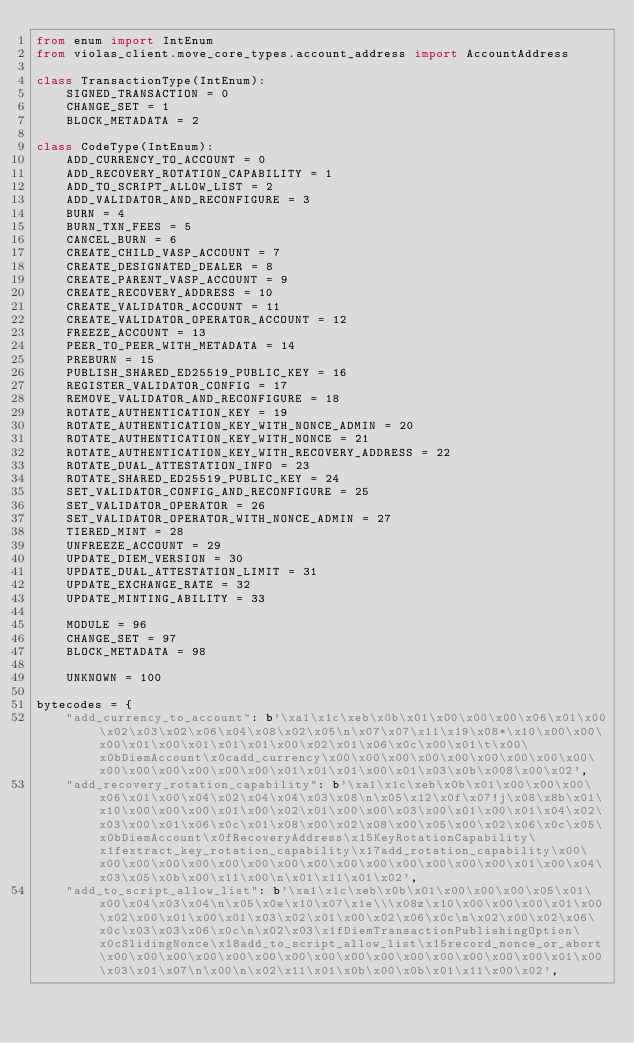Convert code to text. <code><loc_0><loc_0><loc_500><loc_500><_Python_>from enum import IntEnum
from violas_client.move_core_types.account_address import AccountAddress

class TransactionType(IntEnum):
    SIGNED_TRANSACTION = 0
    CHANGE_SET = 1
    BLOCK_METADATA = 2

class CodeType(IntEnum):
    ADD_CURRENCY_TO_ACCOUNT = 0
    ADD_RECOVERY_ROTATION_CAPABILITY = 1
    ADD_TO_SCRIPT_ALLOW_LIST = 2
    ADD_VALIDATOR_AND_RECONFIGURE = 3
    BURN = 4
    BURN_TXN_FEES = 5
    CANCEL_BURN = 6
    CREATE_CHILD_VASP_ACCOUNT = 7
    CREATE_DESIGNATED_DEALER = 8
    CREATE_PARENT_VASP_ACCOUNT = 9
    CREATE_RECOVERY_ADDRESS = 10
    CREATE_VALIDATOR_ACCOUNT = 11
    CREATE_VALIDATOR_OPERATOR_ACCOUNT = 12
    FREEZE_ACCOUNT = 13
    PEER_TO_PEER_WITH_METADATA = 14
    PREBURN = 15
    PUBLISH_SHARED_ED25519_PUBLIC_KEY = 16
    REGISTER_VALIDATOR_CONFIG = 17
    REMOVE_VALIDATOR_AND_RECONFIGURE = 18
    ROTATE_AUTHENTICATION_KEY = 19
    ROTATE_AUTHENTICATION_KEY_WITH_NONCE_ADMIN = 20
    ROTATE_AUTHENTICATION_KEY_WITH_NONCE = 21
    ROTATE_AUTHENTICATION_KEY_WITH_RECOVERY_ADDRESS = 22
    ROTATE_DUAL_ATTESTATION_INFO = 23
    ROTATE_SHARED_ED25519_PUBLIC_KEY = 24
    SET_VALIDATOR_CONFIG_AND_RECONFIGURE = 25
    SET_VALIDATOR_OPERATOR = 26
    SET_VALIDATOR_OPERATOR_WITH_NONCE_ADMIN = 27
    TIERED_MINT = 28
    UNFREEZE_ACCOUNT = 29
    UPDATE_DIEM_VERSION = 30
    UPDATE_DUAL_ATTESTATION_LIMIT = 31
    UPDATE_EXCHANGE_RATE = 32
    UPDATE_MINTING_ABILITY = 33

    MODULE = 96
    CHANGE_SET = 97
    BLOCK_METADATA = 98

    UNKNOWN = 100

bytecodes = {
    "add_currency_to_account": b'\xa1\x1c\xeb\x0b\x01\x00\x00\x00\x06\x01\x00\x02\x03\x02\x06\x04\x08\x02\x05\n\x07\x07\x11\x19\x08*\x10\x00\x00\x00\x01\x00\x01\x01\x01\x00\x02\x01\x06\x0c\x00\x01\t\x00\x0bDiemAccount\x0cadd_currency\x00\x00\x00\x00\x00\x00\x00\x00\x00\x00\x00\x00\x00\x00\x00\x01\x01\x01\x00\x01\x03\x0b\x008\x00\x02',
    "add_recovery_rotation_capability": b'\xa1\x1c\xeb\x0b\x01\x00\x00\x00\x06\x01\x00\x04\x02\x04\x04\x03\x08\n\x05\x12\x0f\x07!j\x08\x8b\x01\x10\x00\x00\x00\x01\x00\x02\x01\x00\x00\x03\x00\x01\x00\x01\x04\x02\x03\x00\x01\x06\x0c\x01\x08\x00\x02\x08\x00\x05\x00\x02\x06\x0c\x05\x0bDiemAccount\x0fRecoveryAddress\x15KeyRotationCapability\x1fextract_key_rotation_capability\x17add_rotation_capability\x00\x00\x00\x00\x00\x00\x00\x00\x00\x00\x00\x00\x00\x00\x00\x01\x00\x04\x03\x05\x0b\x00\x11\x00\n\x01\x11\x01\x02',
    "add_to_script_allow_list": b'\xa1\x1c\xeb\x0b\x01\x00\x00\x00\x05\x01\x00\x04\x03\x04\n\x05\x0e\x10\x07\x1e\\\x08z\x10\x00\x00\x00\x01\x00\x02\x00\x01\x00\x01\x03\x02\x01\x00\x02\x06\x0c\n\x02\x00\x02\x06\x0c\x03\x03\x06\x0c\n\x02\x03\x1fDiemTransactionPublishingOption\x0cSlidingNonce\x18add_to_script_allow_list\x15record_nonce_or_abort\x00\x00\x00\x00\x00\x00\x00\x00\x00\x00\x00\x00\x00\x00\x00\x01\x00\x03\x01\x07\n\x00\n\x02\x11\x01\x0b\x00\x0b\x01\x11\x00\x02',</code> 